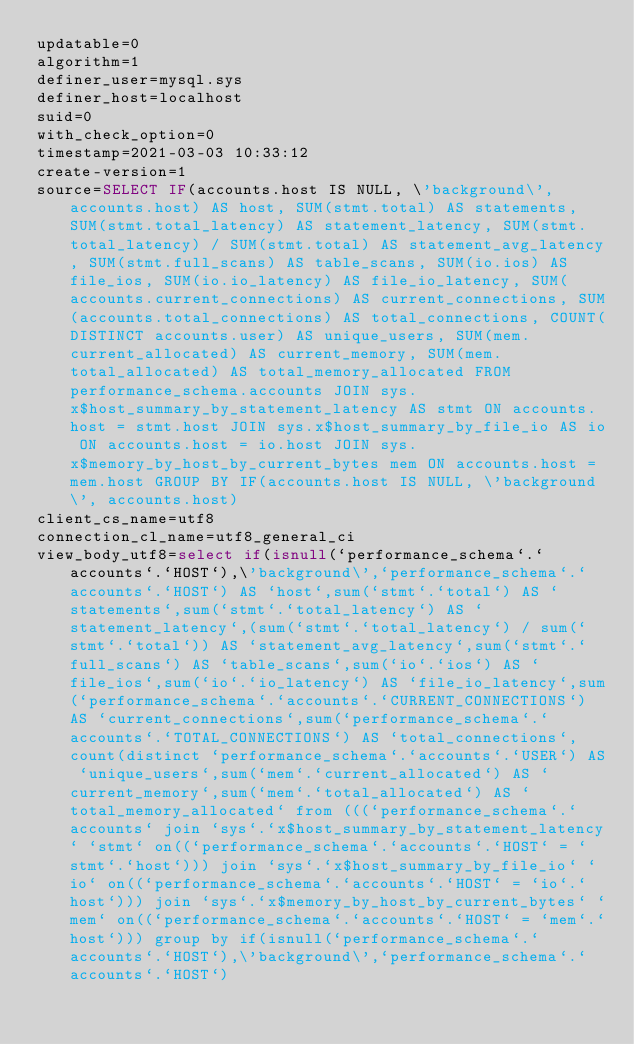Convert code to text. <code><loc_0><loc_0><loc_500><loc_500><_VisualBasic_>updatable=0
algorithm=1
definer_user=mysql.sys
definer_host=localhost
suid=0
with_check_option=0
timestamp=2021-03-03 10:33:12
create-version=1
source=SELECT IF(accounts.host IS NULL, \'background\', accounts.host) AS host, SUM(stmt.total) AS statements, SUM(stmt.total_latency) AS statement_latency, SUM(stmt.total_latency) / SUM(stmt.total) AS statement_avg_latency, SUM(stmt.full_scans) AS table_scans, SUM(io.ios) AS file_ios, SUM(io.io_latency) AS file_io_latency, SUM(accounts.current_connections) AS current_connections, SUM(accounts.total_connections) AS total_connections, COUNT(DISTINCT accounts.user) AS unique_users, SUM(mem.current_allocated) AS current_memory, SUM(mem.total_allocated) AS total_memory_allocated FROM performance_schema.accounts JOIN sys.x$host_summary_by_statement_latency AS stmt ON accounts.host = stmt.host JOIN sys.x$host_summary_by_file_io AS io ON accounts.host = io.host JOIN sys.x$memory_by_host_by_current_bytes mem ON accounts.host = mem.host GROUP BY IF(accounts.host IS NULL, \'background\', accounts.host)
client_cs_name=utf8
connection_cl_name=utf8_general_ci
view_body_utf8=select if(isnull(`performance_schema`.`accounts`.`HOST`),\'background\',`performance_schema`.`accounts`.`HOST`) AS `host`,sum(`stmt`.`total`) AS `statements`,sum(`stmt`.`total_latency`) AS `statement_latency`,(sum(`stmt`.`total_latency`) / sum(`stmt`.`total`)) AS `statement_avg_latency`,sum(`stmt`.`full_scans`) AS `table_scans`,sum(`io`.`ios`) AS `file_ios`,sum(`io`.`io_latency`) AS `file_io_latency`,sum(`performance_schema`.`accounts`.`CURRENT_CONNECTIONS`) AS `current_connections`,sum(`performance_schema`.`accounts`.`TOTAL_CONNECTIONS`) AS `total_connections`,count(distinct `performance_schema`.`accounts`.`USER`) AS `unique_users`,sum(`mem`.`current_allocated`) AS `current_memory`,sum(`mem`.`total_allocated`) AS `total_memory_allocated` from (((`performance_schema`.`accounts` join `sys`.`x$host_summary_by_statement_latency` `stmt` on((`performance_schema`.`accounts`.`HOST` = `stmt`.`host`))) join `sys`.`x$host_summary_by_file_io` `io` on((`performance_schema`.`accounts`.`HOST` = `io`.`host`))) join `sys`.`x$memory_by_host_by_current_bytes` `mem` on((`performance_schema`.`accounts`.`HOST` = `mem`.`host`))) group by if(isnull(`performance_schema`.`accounts`.`HOST`),\'background\',`performance_schema`.`accounts`.`HOST`)
</code> 